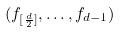Convert formula to latex. <formula><loc_0><loc_0><loc_500><loc_500>( f _ { [ \frac { d } { 2 } ] } , \dots , f _ { d - 1 } )</formula> 